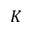<formula> <loc_0><loc_0><loc_500><loc_500>K</formula> 